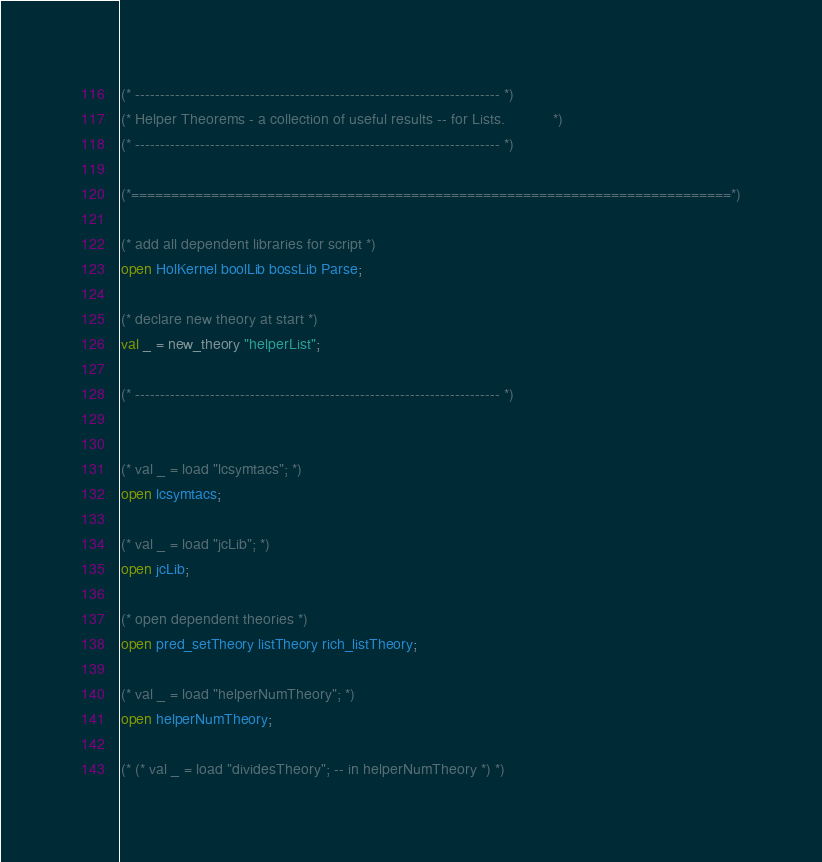Convert code to text. <code><loc_0><loc_0><loc_500><loc_500><_SML_>(* ------------------------------------------------------------------------- *)
(* Helper Theorems - a collection of useful results -- for Lists.            *)
(* ------------------------------------------------------------------------- *)

(*===========================================================================*)

(* add all dependent libraries for script *)
open HolKernel boolLib bossLib Parse;

(* declare new theory at start *)
val _ = new_theory "helperList";

(* ------------------------------------------------------------------------- *)


(* val _ = load "lcsymtacs"; *)
open lcsymtacs;

(* val _ = load "jcLib"; *)
open jcLib;

(* open dependent theories *)
open pred_setTheory listTheory rich_listTheory;

(* val _ = load "helperNumTheory"; *)
open helperNumTheory;

(* (* val _ = load "dividesTheory"; -- in helperNumTheory *) *)</code> 